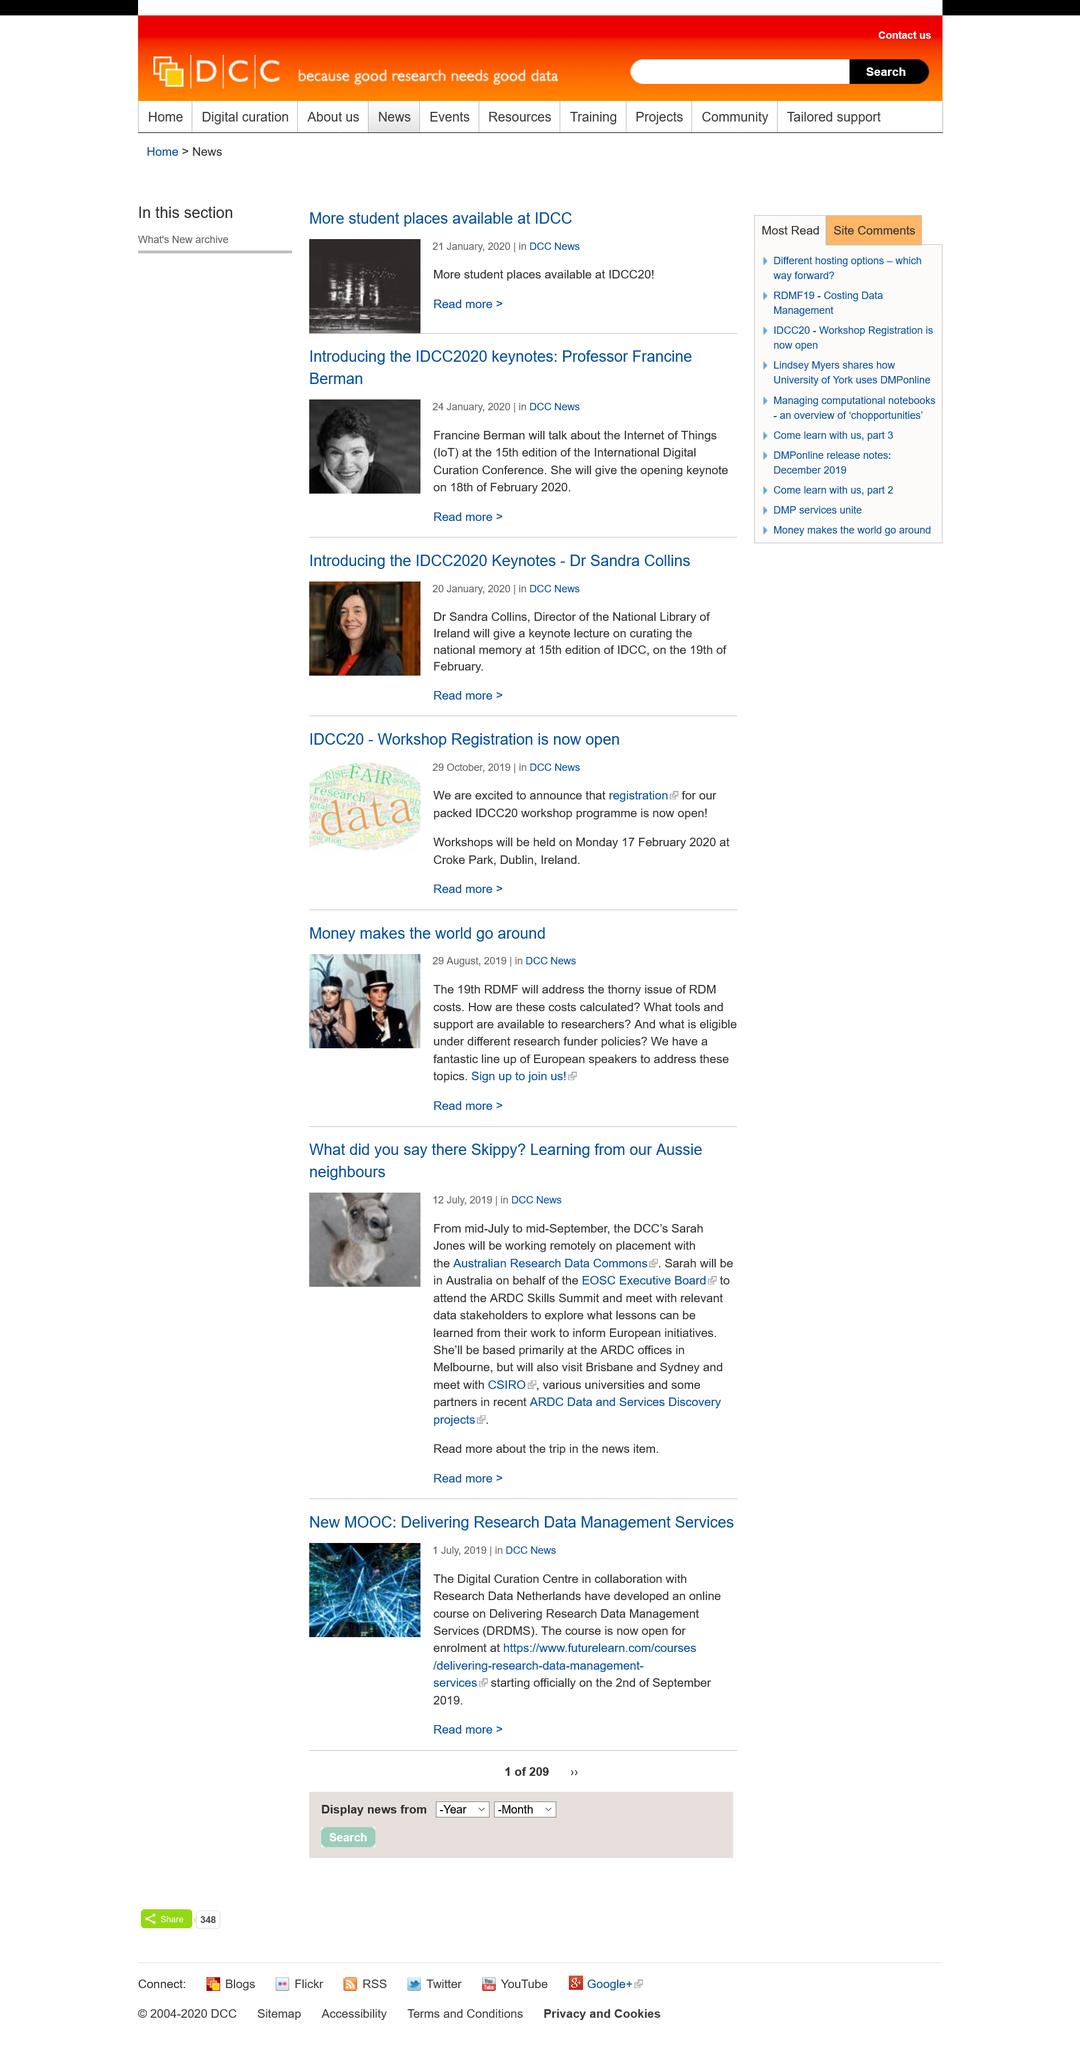Outline some significant characteristics in this image. The Digital Curation Centre and Research Data Netherlands have collaborated to develop an online course on DRDMS. Sarah Jones works for the Digital Curation Centre, which is the full name of the organization she is affiliated with. Sarah Jones will represent the EOSC Executive Board at the ARDC Skills Summit in Australia. 